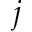<formula> <loc_0><loc_0><loc_500><loc_500>j</formula> 